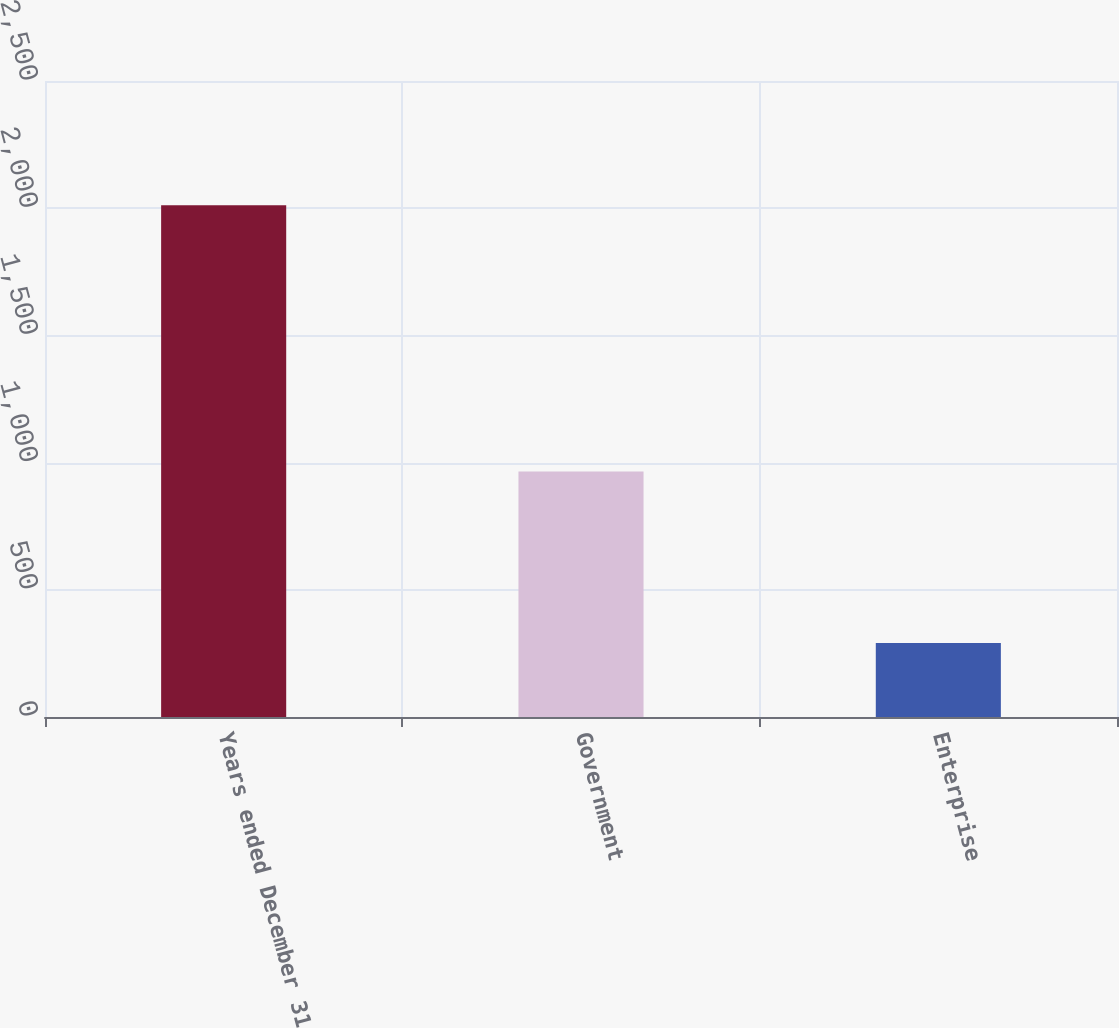<chart> <loc_0><loc_0><loc_500><loc_500><bar_chart><fcel>Years ended December 31<fcel>Government<fcel>Enterprise<nl><fcel>2012<fcel>965<fcel>291<nl></chart> 